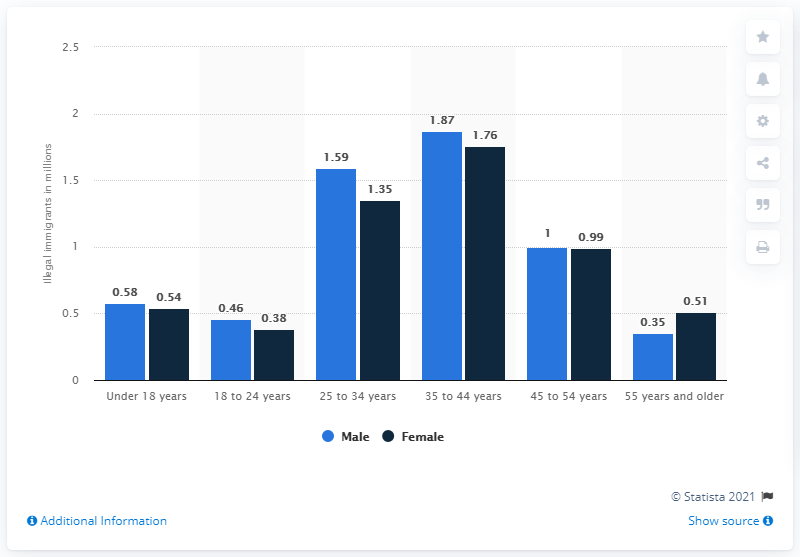Outline some significant characteristics in this image. In January 2018, there were approximately 1.76 female illegal immigrants between the ages of 35 and 44. In January 2018, there were approximately 1.59 million male illegal immigrants between the ages of 25 and 34 living in the United States. 